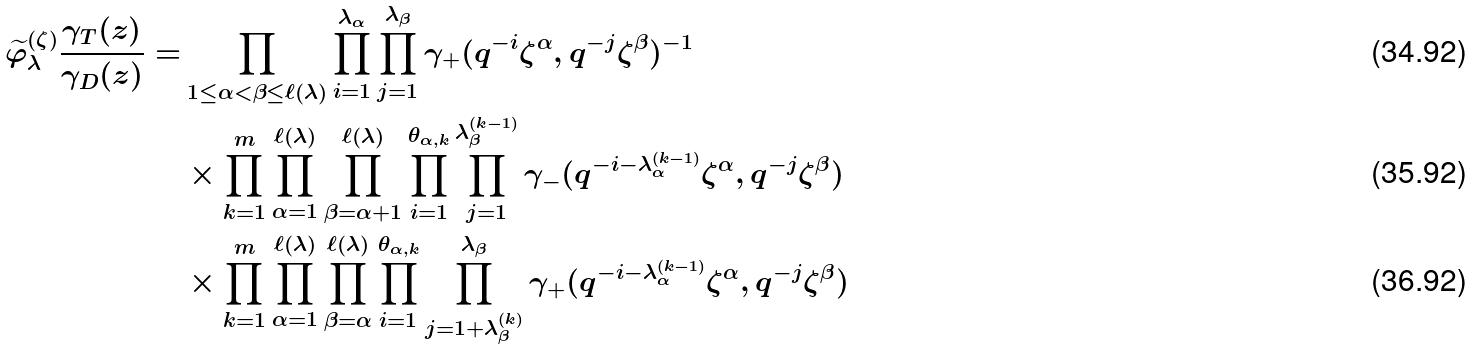<formula> <loc_0><loc_0><loc_500><loc_500>\widetilde { \varphi } ^ { ( \zeta ) } _ { \lambda } \frac { \gamma _ { T } ( z ) } { \gamma _ { D } ( z ) } = & \prod _ { 1 \leq \alpha < \beta \leq \ell ( \lambda ) } \prod _ { i = 1 } ^ { \lambda _ { \alpha } } \prod _ { j = 1 } ^ { \lambda _ { \beta } } \gamma _ { + } ( q ^ { - i } \zeta ^ { \alpha } , q ^ { - j } \zeta ^ { \beta } ) ^ { - 1 } \\ & \times \prod _ { k = 1 } ^ { m } \prod _ { \alpha = 1 } ^ { \ell ( \lambda ) } \prod _ { \beta = \alpha + 1 } ^ { \ell ( \lambda ) } \prod _ { i = 1 } ^ { \theta _ { \alpha , k } } \prod _ { j = 1 } ^ { \lambda _ { \beta } ^ { ( k - 1 ) } } \gamma _ { - } ( q ^ { - i - \lambda _ { \alpha } ^ { ( k - 1 ) } } \zeta ^ { \alpha } , q ^ { - j } \zeta ^ { \beta } ) \\ & \times \prod _ { k = 1 } ^ { m } \prod _ { \alpha = 1 } ^ { \ell ( \lambda ) } \prod _ { \beta = \alpha } ^ { \ell ( \lambda ) } \prod _ { i = 1 } ^ { \theta _ { \alpha , k } } \prod _ { j = 1 + \lambda _ { \beta } ^ { ( k ) } } ^ { \lambda _ { \beta } } \gamma _ { + } ( q ^ { - i - \lambda _ { \alpha } ^ { ( k - 1 ) } } \zeta ^ { \alpha } , q ^ { - j } \zeta ^ { \beta } )</formula> 